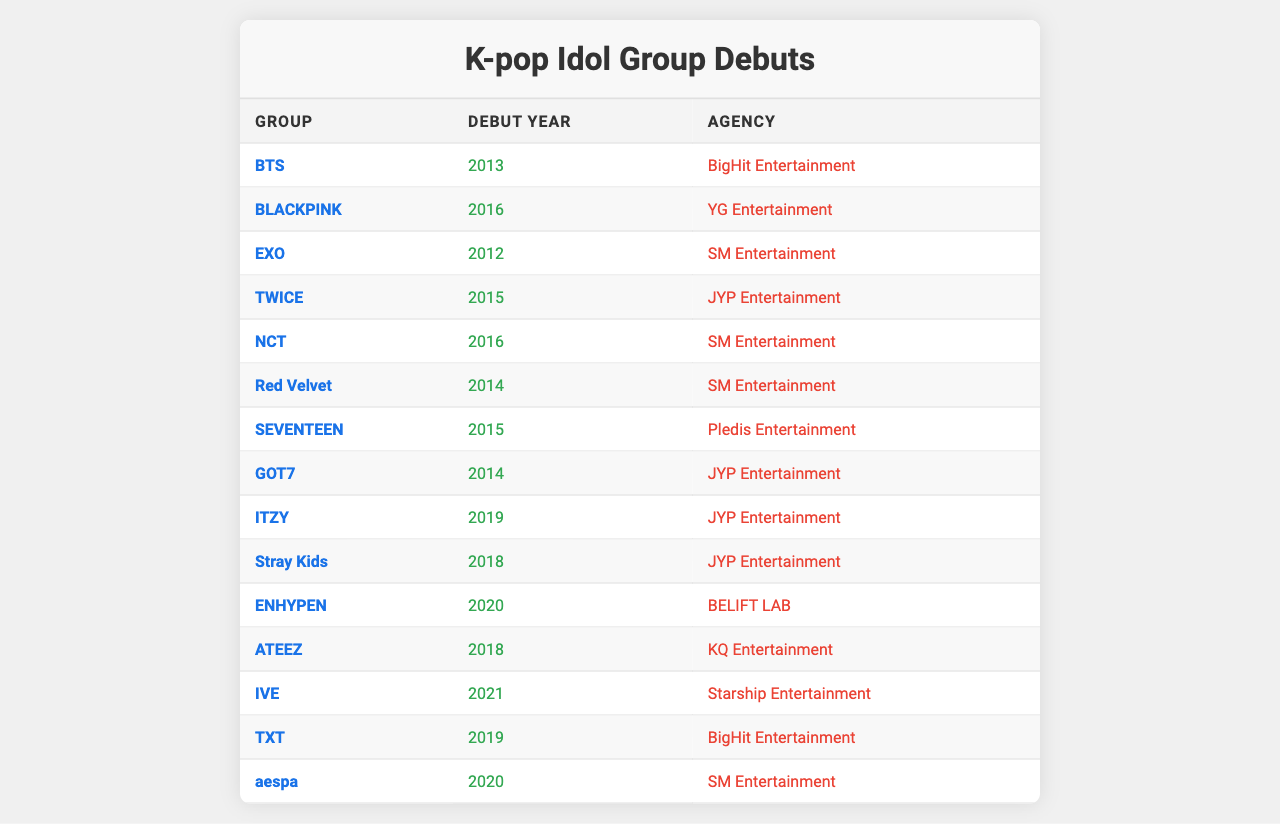What year did BTS debut? By scanning the table, BTS's row shows the year they debuted as 2013.
Answer: 2013 Which group debuted in 2016? The table shows two groups debuting in 2016: BLACKPINK and NCT.
Answer: BLACKPINK, NCT How many groups debuted under JYP Entertainment? By examining the table, GOT7, TWICE, ITZY, Stray Kids are listed under JYP Entertainment, totaling four groups.
Answer: 4 What is the debut year of Red Velvet? The table indicates that Red Velvet debuted in 2014.
Answer: 2014 Which agency did SEVENTEEN belong to? Checking the table, SEVENTEEN's row specifies that they belong to Pledis Entertainment.
Answer: Pledis Entertainment Is it true that aespa debuted before ENHYPEN? Looking at the debut years, aespa debuted in 2020 and ENHYPEN debuted in 2020 as well; therefore, it is false.
Answer: False What is the difference in debut years between TWICE and Stray Kids? TWICE debuted in 2015 and Stray Kids in 2018. The difference is 2018 - 2015 = 3 years.
Answer: 3 years Which agency has the most groups in this table? By counting the rows, JYP Entertainment has four groups, while SM Entertainment has four groups as well, tied for the most groups in this table.
Answer: JYP Entertainment and SM Entertainment What is the median debut year of the groups listed? The debut years are: 2012, 2013, 2014, 2014, 2015, 2015, 2016, 2016, 2018, 2018, 2019, 2019, 2020, 2020, 2021. Arranging them gives 2014 as the median year.
Answer: 2016 Name the group with the latest debut year in this table. Scanning the table shows IVE debuted in 2021, which is the latest year compared to others.
Answer: IVE 